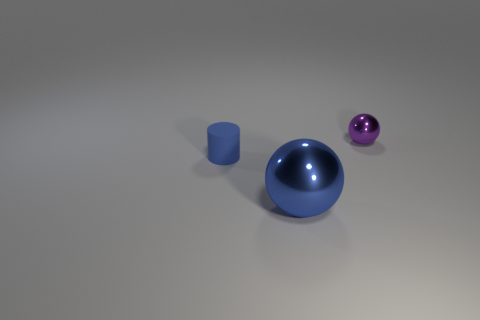The big thing that is the same color as the matte cylinder is what shape?
Ensure brevity in your answer.  Sphere. What is the size of the cylinder that is the same color as the big sphere?
Offer a very short reply. Small. What number of other objects are the same color as the cylinder?
Your response must be concise. 1. There is a shiny object that is on the right side of the big shiny thing; is its shape the same as the tiny object that is in front of the purple thing?
Offer a very short reply. No. Are there an equal number of large metal spheres that are behind the cylinder and shiny things that are in front of the small purple ball?
Keep it short and to the point. No. What shape is the tiny object left of the metallic sphere in front of the sphere that is behind the tiny blue thing?
Provide a short and direct response. Cylinder. Are the tiny purple thing that is on the right side of the blue ball and the blue thing that is in front of the tiny blue matte thing made of the same material?
Your answer should be very brief. Yes. What shape is the metallic thing behind the small rubber thing?
Provide a succinct answer. Sphere. Are there fewer blue metal objects than tiny brown blocks?
Provide a short and direct response. No. Is there a tiny blue thing behind the shiny object in front of the metallic object behind the blue cylinder?
Your answer should be compact. Yes. 